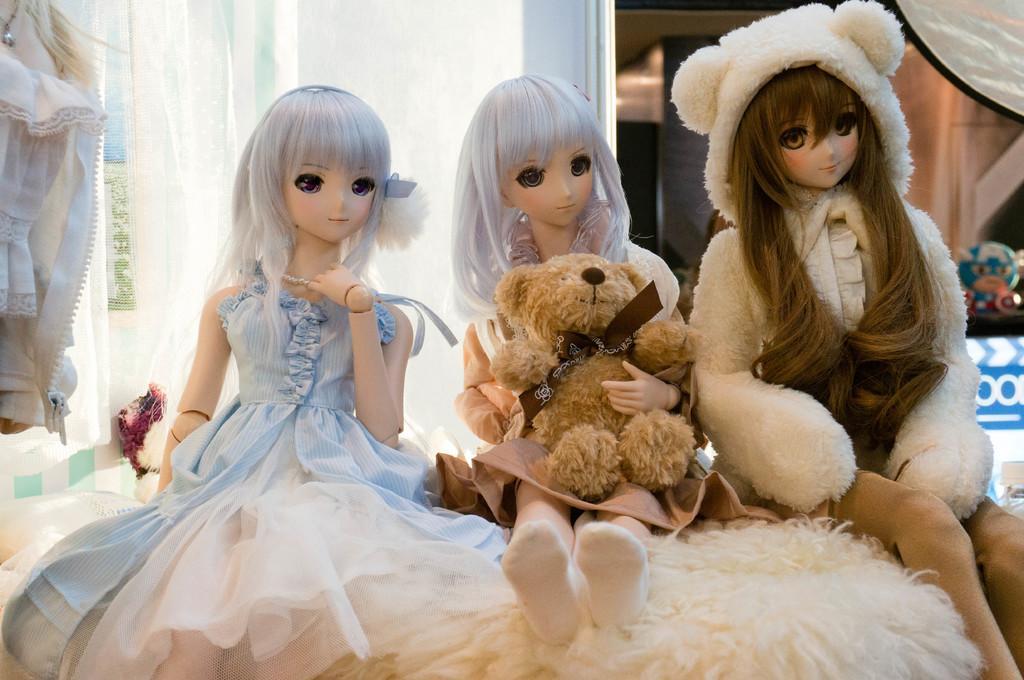Can you describe this image briefly? Here we can see dolls. Background it is blur. Far there is a toy. 